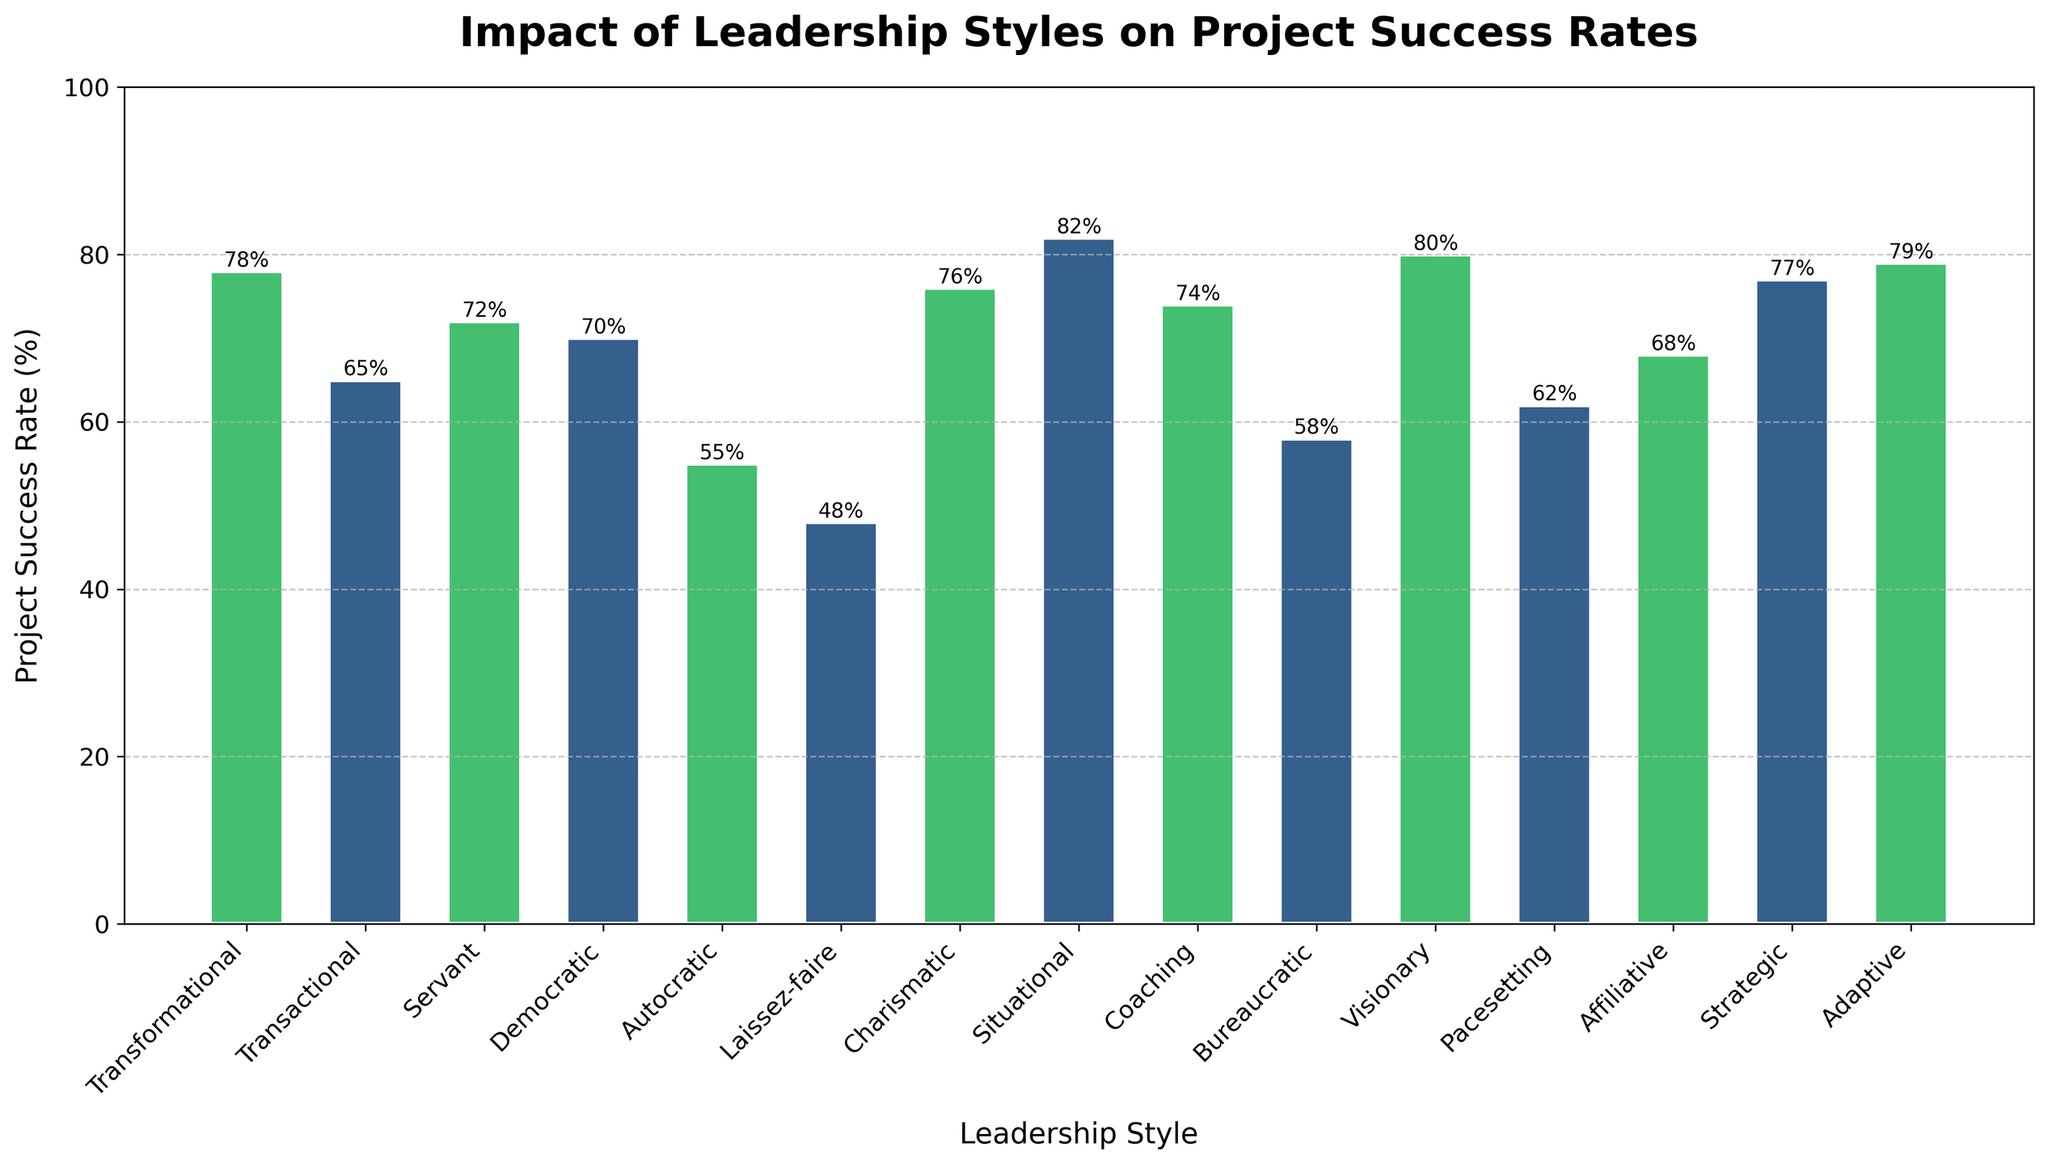Which leadership style has the highest project success rate? Look at the height of the bars to identify the tallest one. The tallest bar represents the 'Situational' leadership style with a success rate of 82%.
Answer: Situational Which leadership style has the lowest project success rate? Identify the shortest bar in the bar chart. The shortest bar represents the 'Laissez-faire' leadership style with a success rate of 48%.
Answer: Laissez-faire How much higher is the success rate for Visionary leadership compared to Transactional leadership? Look at the heights of the bars corresponding to 'Visionary' and 'Transactional' leadership styles. Visionary has a success rate of 80%, while Transactional has 65%. Subtract 65% from 80%.
Answer: 15% What is the average project success rate of Transformational, Servant, and Visionary leadership styles? Locate the bars for Transformational (78%), Servant (72%), and Visionary (80%). Sum these rates: 78% + 72% + 80% = 230%. Divide by 3 to find the average: 230 / 3 ≈ 76.67%.
Answer: 76.67% Which leadership style has a project success rate closest to the average success rate of all leadership styles? Calculate the average success rate of all styles: (78+65+72+70+55+48+76+82+74+58+80+62+68+77+79) / 15 = 69.33%. The 'Democratic' leadership style at 70% is closest to this average.
Answer: Democratic What is the difference in project success rates between Adaptive and Pacesetting leadership styles? Locate the bars for Adaptive (79%) and Pacesetting (62%). Subtract the smaller value from the larger one: 79% - 62% = 17%.
Answer: 17% Which leadership styles have a success rate above 75%? Identify bars with heights above 75%. The leadership styles are Transformational (78%), Situational (82%), Charismatic (76%), Visionary (80%), Strategic (77%), and Adaptive (79%).
Answer: Transformational, Situational, Charismatic, Visionary, Strategic, Adaptive Does the 'Autocratic' leadership style have a higher or lower project success rate than 'Bureaucratic'? Compare the heights of the bars for 'Autocratic' (55%) and 'Bureaucratic' (58%). Autocratic is lower.
Answer: Lower 